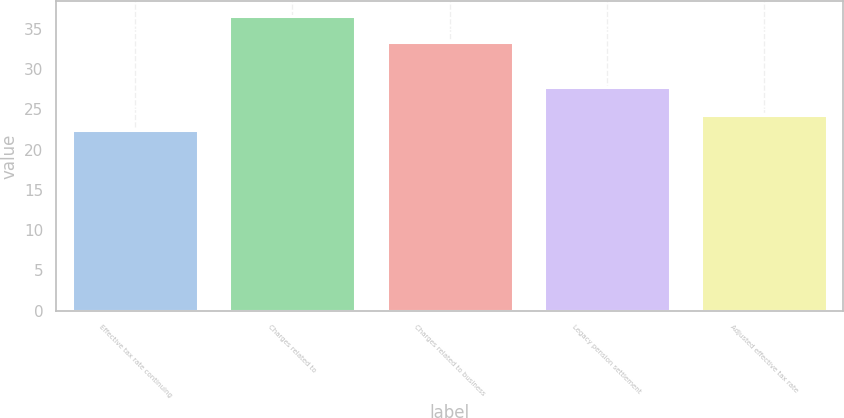<chart> <loc_0><loc_0><loc_500><loc_500><bar_chart><fcel>Effective tax rate continuing<fcel>Charges related to<fcel>Charges related to business<fcel>Legacy pension settlement<fcel>Adjusted effective tax rate<nl><fcel>22.4<fcel>36.6<fcel>33.3<fcel>27.8<fcel>24.3<nl></chart> 